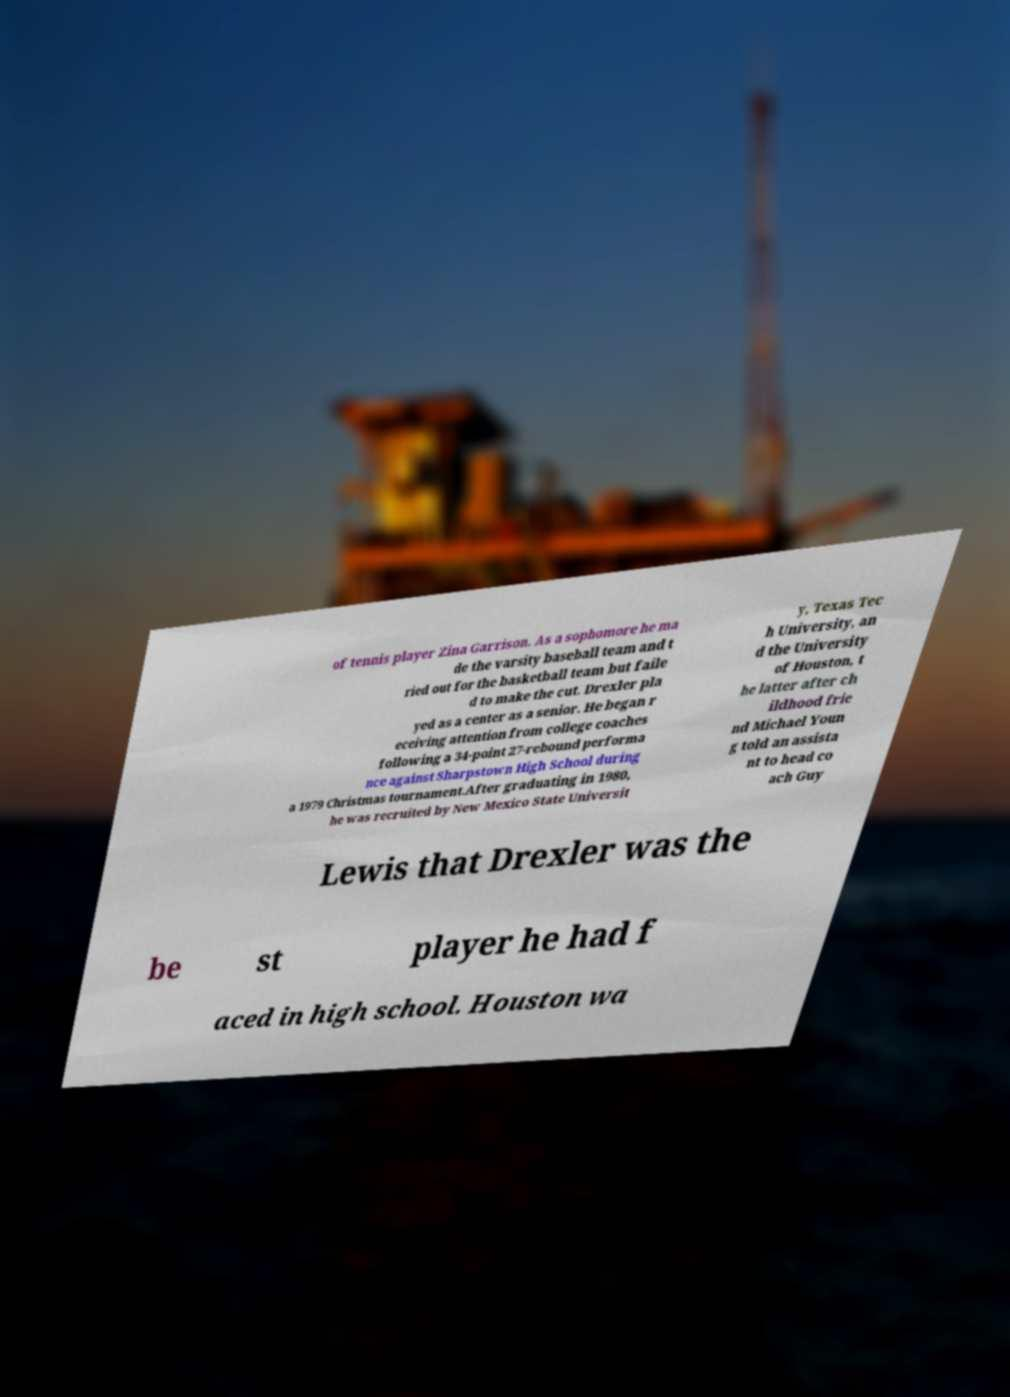Please read and relay the text visible in this image. What does it say? of tennis player Zina Garrison. As a sophomore he ma de the varsity baseball team and t ried out for the basketball team but faile d to make the cut. Drexler pla yed as a center as a senior. He began r eceiving attention from college coaches following a 34-point 27-rebound performa nce against Sharpstown High School during a 1979 Christmas tournament.After graduating in 1980, he was recruited by New Mexico State Universit y, Texas Tec h University, an d the University of Houston, t he latter after ch ildhood frie nd Michael Youn g told an assista nt to head co ach Guy Lewis that Drexler was the be st player he had f aced in high school. Houston wa 